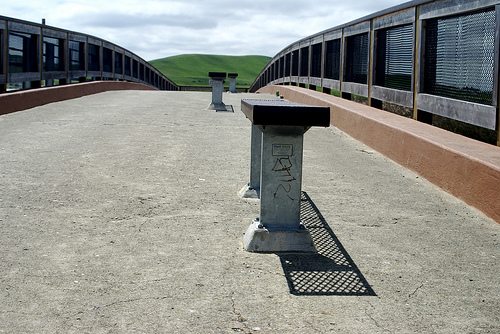<image>
Is there a hill on the bench? No. The hill is not positioned on the bench. They may be near each other, but the hill is not supported by or resting on top of the bench. 